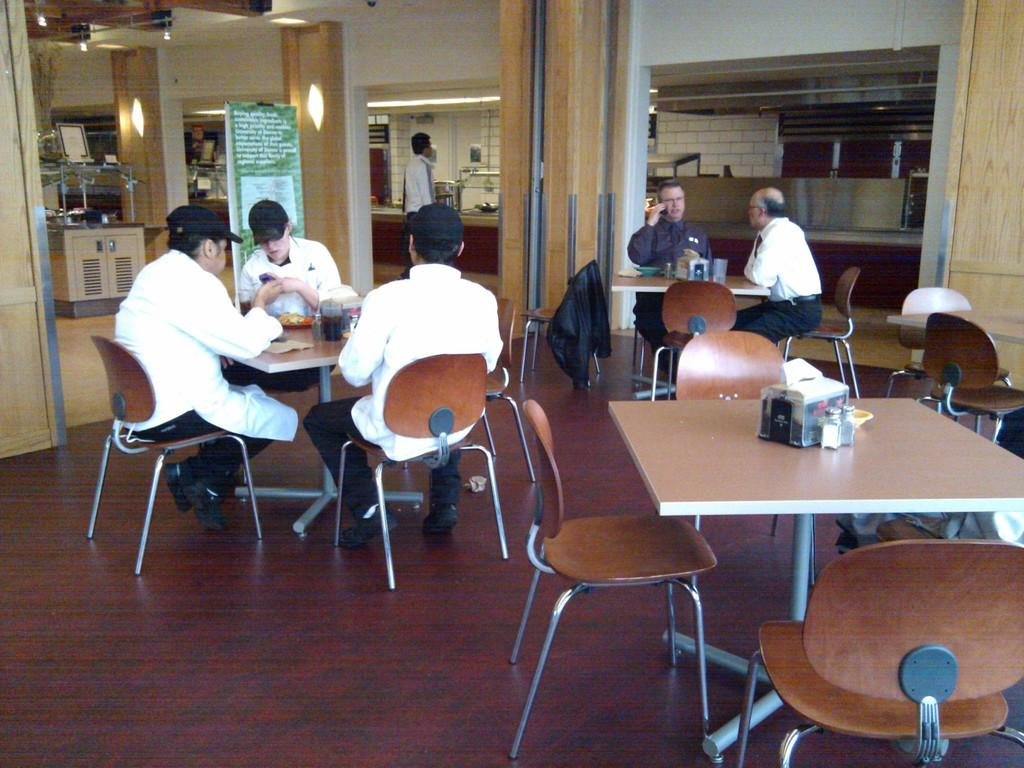What type of furniture is present in the image? There are tables and chairs in the image. What are the people in the image doing? There are groups of people sitting on the tables and chairs. What type of advertisement can be seen on the tables in the image? There is no advertisement present on the tables in the image. What time does the watch in the image show? There is no watch present in the image. 